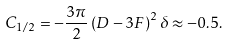Convert formula to latex. <formula><loc_0><loc_0><loc_500><loc_500>C _ { 1 / 2 } = - \frac { 3 \pi } { 2 } \left ( D - 3 F \right ) ^ { 2 } \delta \approx - 0 . 5 .</formula> 